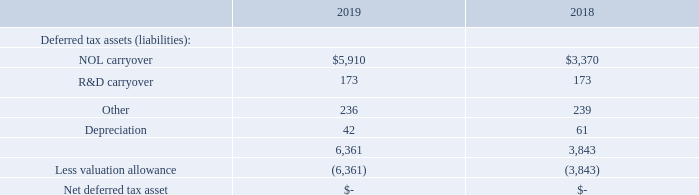Deferred taxes are provided on a liability method whereby deferred tax assets are recognized for deductible differences and operating loss and tax credit carry-forwards and deferred tax liabilities are recognized for taxable temporary differences. Temporary differences are the difference between the reported amounts of assets and liabilities and their tax bases. Deferred tax assets are reduced by a valuation allowance when, in the opinion of management, it is more likely than not that some portion or all of the deferred tax assets will not be realized. Deferred tax assets and liabilities are adjusted for the effects of changes in tax laws and rates on the date of enactment.
At December 31, 2019, the Company had net operating loss carry-forwards of approximately $21.6 million that may be offset against future taxable income indefinitely. No tax benefit has been reported in the 2019 financial statements, since the potential tax benefit is offset by a valuation allowance of the same amount.
Net deferred tax assets consist of the following components as of December 31, 2019 and 2018:
Due to the change in ownership provisions of the Tax Reform Act of 1986, net operating loss carry-forwards for federal income tax reporting purposes are subject to annual limitations. Should a change in ownership occur, net operating loss carry-forwards may be limited as to use in future years.
What is the net operating loss carry-forwards at December 31, 2019? $21.6 million. What is the  NOL carryover for 2019? $5,910. How are deferred tax assets and liabilities adjusted? Adjusted for the effects of changes in tax laws and rates on the date of enactment. What is the percentage change in the total deferred tax assets from 2018 to 2019?
Answer scale should be: percent. (6,361-3,843)/3,843
Answer: 65.52. What is the percentage of R&D carryover in the total deferred tax assets in 2019?
Answer scale should be: percent. 173/6,361
Answer: 2.72. What is the percentage of depreciation in the total deferred tax assets in 2018?
Answer scale should be: percent. 61/3,843
Answer: 1.59. In which year is the NOL carryover higher? Find the year with the higher NOL carryover
Answer: 2019. 